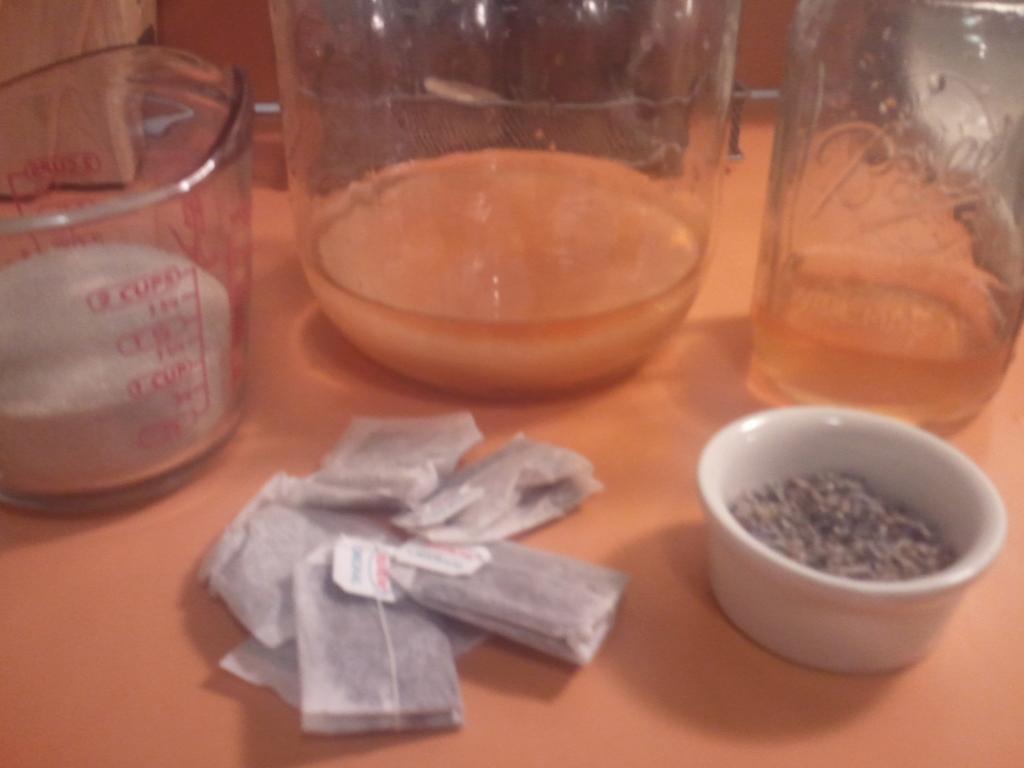How many cups does this measuring cup hold?
Your answer should be compact. 2. What kind of measurements does it show?
Offer a terse response. Cups. 